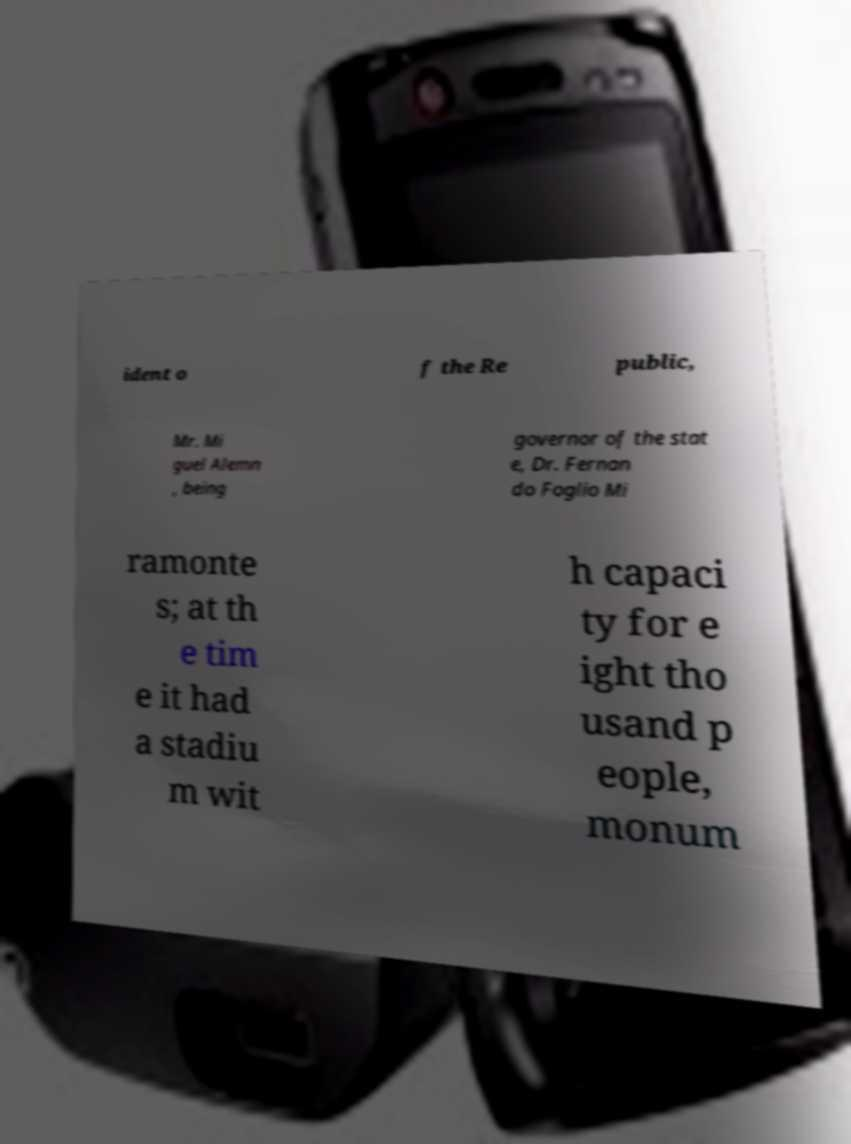Can you read and provide the text displayed in the image?This photo seems to have some interesting text. Can you extract and type it out for me? ident o f the Re public, Mr. Mi guel Alemn , being governor of the stat e, Dr. Fernan do Foglio Mi ramonte s; at th e tim e it had a stadiu m wit h capaci ty for e ight tho usand p eople, monum 